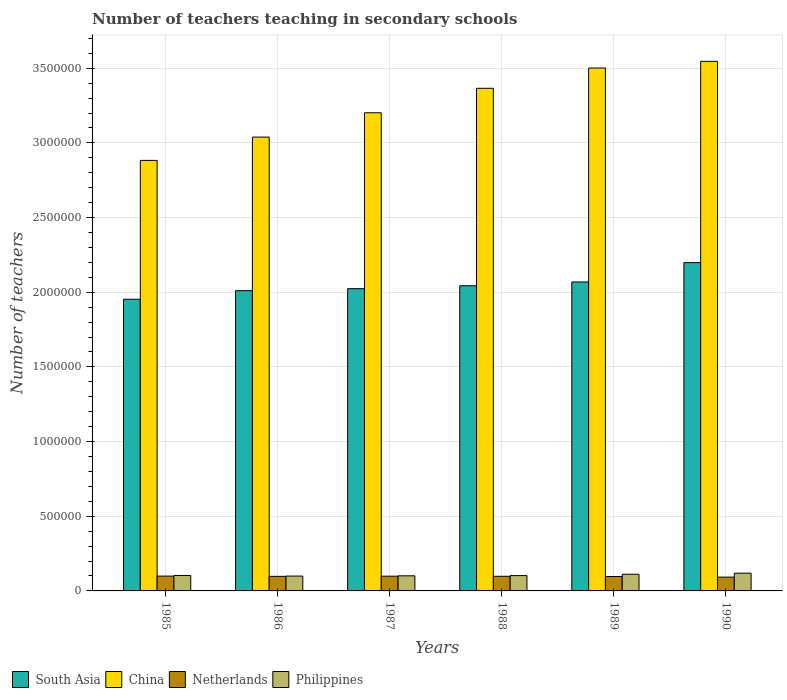Are the number of bars per tick equal to the number of legend labels?
Provide a succinct answer. Yes. How many bars are there on the 6th tick from the left?
Keep it short and to the point. 4. What is the number of teachers teaching in secondary schools in South Asia in 1989?
Ensure brevity in your answer.  2.07e+06. Across all years, what is the maximum number of teachers teaching in secondary schools in Philippines?
Your response must be concise. 1.19e+05. Across all years, what is the minimum number of teachers teaching in secondary schools in Netherlands?
Ensure brevity in your answer.  9.24e+04. In which year was the number of teachers teaching in secondary schools in South Asia maximum?
Your answer should be very brief. 1990. What is the total number of teachers teaching in secondary schools in Netherlands in the graph?
Ensure brevity in your answer.  5.82e+05. What is the difference between the number of teachers teaching in secondary schools in South Asia in 1985 and that in 1986?
Your response must be concise. -5.73e+04. What is the difference between the number of teachers teaching in secondary schools in South Asia in 1986 and the number of teachers teaching in secondary schools in China in 1990?
Provide a succinct answer. -1.54e+06. What is the average number of teachers teaching in secondary schools in South Asia per year?
Provide a succinct answer. 2.05e+06. In the year 1986, what is the difference between the number of teachers teaching in secondary schools in South Asia and number of teachers teaching in secondary schools in China?
Give a very brief answer. -1.03e+06. What is the ratio of the number of teachers teaching in secondary schools in Netherlands in 1986 to that in 1990?
Provide a short and direct response. 1.06. Is the number of teachers teaching in secondary schools in Philippines in 1986 less than that in 1989?
Provide a short and direct response. Yes. What is the difference between the highest and the second highest number of teachers teaching in secondary schools in South Asia?
Your answer should be compact. 1.30e+05. What is the difference between the highest and the lowest number of teachers teaching in secondary schools in China?
Ensure brevity in your answer.  6.63e+05. Is the sum of the number of teachers teaching in secondary schools in South Asia in 1986 and 1990 greater than the maximum number of teachers teaching in secondary schools in Netherlands across all years?
Give a very brief answer. Yes. What does the 3rd bar from the left in 1986 represents?
Your response must be concise. Netherlands. What does the 4th bar from the right in 1989 represents?
Offer a very short reply. South Asia. How many bars are there?
Give a very brief answer. 24. How many years are there in the graph?
Your answer should be very brief. 6. Are the values on the major ticks of Y-axis written in scientific E-notation?
Give a very brief answer. No. How many legend labels are there?
Your response must be concise. 4. How are the legend labels stacked?
Offer a very short reply. Horizontal. What is the title of the graph?
Your response must be concise. Number of teachers teaching in secondary schools. What is the label or title of the Y-axis?
Offer a very short reply. Number of teachers. What is the Number of teachers of South Asia in 1985?
Provide a succinct answer. 1.95e+06. What is the Number of teachers of China in 1985?
Keep it short and to the point. 2.88e+06. What is the Number of teachers in Netherlands in 1985?
Provide a succinct answer. 9.93e+04. What is the Number of teachers of Philippines in 1985?
Offer a very short reply. 1.03e+05. What is the Number of teachers in South Asia in 1986?
Offer a terse response. 2.01e+06. What is the Number of teachers of China in 1986?
Offer a very short reply. 3.04e+06. What is the Number of teachers in Netherlands in 1986?
Give a very brief answer. 9.76e+04. What is the Number of teachers of Philippines in 1986?
Keep it short and to the point. 9.95e+04. What is the Number of teachers of South Asia in 1987?
Make the answer very short. 2.02e+06. What is the Number of teachers in China in 1987?
Ensure brevity in your answer.  3.20e+06. What is the Number of teachers of Netherlands in 1987?
Keep it short and to the point. 9.87e+04. What is the Number of teachers in Philippines in 1987?
Ensure brevity in your answer.  1.01e+05. What is the Number of teachers of South Asia in 1988?
Ensure brevity in your answer.  2.04e+06. What is the Number of teachers of China in 1988?
Your response must be concise. 3.37e+06. What is the Number of teachers of Netherlands in 1988?
Ensure brevity in your answer.  9.80e+04. What is the Number of teachers of Philippines in 1988?
Keep it short and to the point. 1.03e+05. What is the Number of teachers of South Asia in 1989?
Ensure brevity in your answer.  2.07e+06. What is the Number of teachers of China in 1989?
Give a very brief answer. 3.50e+06. What is the Number of teachers in Netherlands in 1989?
Your response must be concise. 9.64e+04. What is the Number of teachers of Philippines in 1989?
Your response must be concise. 1.12e+05. What is the Number of teachers of South Asia in 1990?
Provide a short and direct response. 2.20e+06. What is the Number of teachers in China in 1990?
Your answer should be compact. 3.55e+06. What is the Number of teachers of Netherlands in 1990?
Offer a terse response. 9.24e+04. What is the Number of teachers in Philippines in 1990?
Provide a succinct answer. 1.19e+05. Across all years, what is the maximum Number of teachers of South Asia?
Offer a terse response. 2.20e+06. Across all years, what is the maximum Number of teachers of China?
Your answer should be very brief. 3.55e+06. Across all years, what is the maximum Number of teachers in Netherlands?
Offer a terse response. 9.93e+04. Across all years, what is the maximum Number of teachers in Philippines?
Provide a short and direct response. 1.19e+05. Across all years, what is the minimum Number of teachers of South Asia?
Offer a very short reply. 1.95e+06. Across all years, what is the minimum Number of teachers of China?
Keep it short and to the point. 2.88e+06. Across all years, what is the minimum Number of teachers in Netherlands?
Provide a succinct answer. 9.24e+04. Across all years, what is the minimum Number of teachers of Philippines?
Make the answer very short. 9.95e+04. What is the total Number of teachers in South Asia in the graph?
Your answer should be very brief. 1.23e+07. What is the total Number of teachers of China in the graph?
Provide a succinct answer. 1.95e+07. What is the total Number of teachers in Netherlands in the graph?
Ensure brevity in your answer.  5.82e+05. What is the total Number of teachers in Philippines in the graph?
Give a very brief answer. 6.37e+05. What is the difference between the Number of teachers of South Asia in 1985 and that in 1986?
Keep it short and to the point. -5.73e+04. What is the difference between the Number of teachers of China in 1985 and that in 1986?
Your answer should be very brief. -1.56e+05. What is the difference between the Number of teachers of Netherlands in 1985 and that in 1986?
Give a very brief answer. 1668. What is the difference between the Number of teachers of Philippines in 1985 and that in 1986?
Your response must be concise. 4025. What is the difference between the Number of teachers of South Asia in 1985 and that in 1987?
Offer a very short reply. -7.08e+04. What is the difference between the Number of teachers of China in 1985 and that in 1987?
Ensure brevity in your answer.  -3.19e+05. What is the difference between the Number of teachers of Netherlands in 1985 and that in 1987?
Offer a terse response. 534. What is the difference between the Number of teachers of Philippines in 1985 and that in 1987?
Keep it short and to the point. 2411. What is the difference between the Number of teachers of South Asia in 1985 and that in 1988?
Ensure brevity in your answer.  -9.04e+04. What is the difference between the Number of teachers of China in 1985 and that in 1988?
Provide a short and direct response. -4.83e+05. What is the difference between the Number of teachers of Netherlands in 1985 and that in 1988?
Provide a short and direct response. 1261. What is the difference between the Number of teachers of Philippines in 1985 and that in 1988?
Provide a short and direct response. 882. What is the difference between the Number of teachers in South Asia in 1985 and that in 1989?
Your answer should be compact. -1.16e+05. What is the difference between the Number of teachers in China in 1985 and that in 1989?
Provide a succinct answer. -6.18e+05. What is the difference between the Number of teachers of Netherlands in 1985 and that in 1989?
Offer a very short reply. 2882. What is the difference between the Number of teachers in Philippines in 1985 and that in 1989?
Your answer should be very brief. -8241. What is the difference between the Number of teachers of South Asia in 1985 and that in 1990?
Offer a very short reply. -2.45e+05. What is the difference between the Number of teachers of China in 1985 and that in 1990?
Your answer should be very brief. -6.63e+05. What is the difference between the Number of teachers in Netherlands in 1985 and that in 1990?
Your answer should be compact. 6819. What is the difference between the Number of teachers in Philippines in 1985 and that in 1990?
Keep it short and to the point. -1.53e+04. What is the difference between the Number of teachers of South Asia in 1986 and that in 1987?
Keep it short and to the point. -1.35e+04. What is the difference between the Number of teachers in China in 1986 and that in 1987?
Keep it short and to the point. -1.63e+05. What is the difference between the Number of teachers in Netherlands in 1986 and that in 1987?
Provide a succinct answer. -1134. What is the difference between the Number of teachers in Philippines in 1986 and that in 1987?
Keep it short and to the point. -1614. What is the difference between the Number of teachers of South Asia in 1986 and that in 1988?
Provide a succinct answer. -3.31e+04. What is the difference between the Number of teachers of China in 1986 and that in 1988?
Make the answer very short. -3.27e+05. What is the difference between the Number of teachers of Netherlands in 1986 and that in 1988?
Ensure brevity in your answer.  -407. What is the difference between the Number of teachers of Philippines in 1986 and that in 1988?
Offer a very short reply. -3143. What is the difference between the Number of teachers in South Asia in 1986 and that in 1989?
Ensure brevity in your answer.  -5.83e+04. What is the difference between the Number of teachers of China in 1986 and that in 1989?
Provide a succinct answer. -4.62e+05. What is the difference between the Number of teachers in Netherlands in 1986 and that in 1989?
Offer a very short reply. 1214. What is the difference between the Number of teachers of Philippines in 1986 and that in 1989?
Keep it short and to the point. -1.23e+04. What is the difference between the Number of teachers of South Asia in 1986 and that in 1990?
Offer a terse response. -1.88e+05. What is the difference between the Number of teachers in China in 1986 and that in 1990?
Provide a short and direct response. -5.07e+05. What is the difference between the Number of teachers in Netherlands in 1986 and that in 1990?
Make the answer very short. 5151. What is the difference between the Number of teachers of Philippines in 1986 and that in 1990?
Provide a short and direct response. -1.93e+04. What is the difference between the Number of teachers in South Asia in 1987 and that in 1988?
Your response must be concise. -1.96e+04. What is the difference between the Number of teachers in China in 1987 and that in 1988?
Give a very brief answer. -1.64e+05. What is the difference between the Number of teachers in Netherlands in 1987 and that in 1988?
Your answer should be compact. 727. What is the difference between the Number of teachers of Philippines in 1987 and that in 1988?
Keep it short and to the point. -1529. What is the difference between the Number of teachers in South Asia in 1987 and that in 1989?
Your answer should be very brief. -4.48e+04. What is the difference between the Number of teachers of China in 1987 and that in 1989?
Give a very brief answer. -3.00e+05. What is the difference between the Number of teachers in Netherlands in 1987 and that in 1989?
Provide a short and direct response. 2348. What is the difference between the Number of teachers of Philippines in 1987 and that in 1989?
Provide a short and direct response. -1.07e+04. What is the difference between the Number of teachers of South Asia in 1987 and that in 1990?
Keep it short and to the point. -1.75e+05. What is the difference between the Number of teachers of China in 1987 and that in 1990?
Provide a succinct answer. -3.44e+05. What is the difference between the Number of teachers of Netherlands in 1987 and that in 1990?
Make the answer very short. 6285. What is the difference between the Number of teachers of Philippines in 1987 and that in 1990?
Give a very brief answer. -1.77e+04. What is the difference between the Number of teachers in South Asia in 1988 and that in 1989?
Ensure brevity in your answer.  -2.53e+04. What is the difference between the Number of teachers in China in 1988 and that in 1989?
Make the answer very short. -1.36e+05. What is the difference between the Number of teachers of Netherlands in 1988 and that in 1989?
Ensure brevity in your answer.  1621. What is the difference between the Number of teachers in Philippines in 1988 and that in 1989?
Make the answer very short. -9123. What is the difference between the Number of teachers in South Asia in 1988 and that in 1990?
Your answer should be compact. -1.55e+05. What is the difference between the Number of teachers in China in 1988 and that in 1990?
Offer a terse response. -1.80e+05. What is the difference between the Number of teachers in Netherlands in 1988 and that in 1990?
Provide a short and direct response. 5558. What is the difference between the Number of teachers in Philippines in 1988 and that in 1990?
Your response must be concise. -1.62e+04. What is the difference between the Number of teachers in South Asia in 1989 and that in 1990?
Your response must be concise. -1.30e+05. What is the difference between the Number of teachers in China in 1989 and that in 1990?
Your response must be concise. -4.47e+04. What is the difference between the Number of teachers of Netherlands in 1989 and that in 1990?
Your answer should be compact. 3937. What is the difference between the Number of teachers of Philippines in 1989 and that in 1990?
Your answer should be compact. -7071. What is the difference between the Number of teachers in South Asia in 1985 and the Number of teachers in China in 1986?
Make the answer very short. -1.09e+06. What is the difference between the Number of teachers of South Asia in 1985 and the Number of teachers of Netherlands in 1986?
Your answer should be compact. 1.86e+06. What is the difference between the Number of teachers of South Asia in 1985 and the Number of teachers of Philippines in 1986?
Your answer should be compact. 1.85e+06. What is the difference between the Number of teachers in China in 1985 and the Number of teachers in Netherlands in 1986?
Keep it short and to the point. 2.79e+06. What is the difference between the Number of teachers of China in 1985 and the Number of teachers of Philippines in 1986?
Offer a very short reply. 2.78e+06. What is the difference between the Number of teachers of Netherlands in 1985 and the Number of teachers of Philippines in 1986?
Provide a short and direct response. -205. What is the difference between the Number of teachers of South Asia in 1985 and the Number of teachers of China in 1987?
Make the answer very short. -1.25e+06. What is the difference between the Number of teachers in South Asia in 1985 and the Number of teachers in Netherlands in 1987?
Give a very brief answer. 1.85e+06. What is the difference between the Number of teachers in South Asia in 1985 and the Number of teachers in Philippines in 1987?
Your answer should be compact. 1.85e+06. What is the difference between the Number of teachers of China in 1985 and the Number of teachers of Netherlands in 1987?
Your answer should be very brief. 2.78e+06. What is the difference between the Number of teachers of China in 1985 and the Number of teachers of Philippines in 1987?
Offer a terse response. 2.78e+06. What is the difference between the Number of teachers in Netherlands in 1985 and the Number of teachers in Philippines in 1987?
Give a very brief answer. -1819. What is the difference between the Number of teachers of South Asia in 1985 and the Number of teachers of China in 1988?
Provide a short and direct response. -1.41e+06. What is the difference between the Number of teachers in South Asia in 1985 and the Number of teachers in Netherlands in 1988?
Your answer should be compact. 1.86e+06. What is the difference between the Number of teachers of South Asia in 1985 and the Number of teachers of Philippines in 1988?
Your response must be concise. 1.85e+06. What is the difference between the Number of teachers in China in 1985 and the Number of teachers in Netherlands in 1988?
Ensure brevity in your answer.  2.78e+06. What is the difference between the Number of teachers of China in 1985 and the Number of teachers of Philippines in 1988?
Your answer should be very brief. 2.78e+06. What is the difference between the Number of teachers of Netherlands in 1985 and the Number of teachers of Philippines in 1988?
Give a very brief answer. -3348. What is the difference between the Number of teachers in South Asia in 1985 and the Number of teachers in China in 1989?
Your answer should be very brief. -1.55e+06. What is the difference between the Number of teachers in South Asia in 1985 and the Number of teachers in Netherlands in 1989?
Ensure brevity in your answer.  1.86e+06. What is the difference between the Number of teachers in South Asia in 1985 and the Number of teachers in Philippines in 1989?
Provide a short and direct response. 1.84e+06. What is the difference between the Number of teachers in China in 1985 and the Number of teachers in Netherlands in 1989?
Offer a very short reply. 2.79e+06. What is the difference between the Number of teachers of China in 1985 and the Number of teachers of Philippines in 1989?
Make the answer very short. 2.77e+06. What is the difference between the Number of teachers in Netherlands in 1985 and the Number of teachers in Philippines in 1989?
Your answer should be very brief. -1.25e+04. What is the difference between the Number of teachers of South Asia in 1985 and the Number of teachers of China in 1990?
Your answer should be compact. -1.59e+06. What is the difference between the Number of teachers in South Asia in 1985 and the Number of teachers in Netherlands in 1990?
Keep it short and to the point. 1.86e+06. What is the difference between the Number of teachers in South Asia in 1985 and the Number of teachers in Philippines in 1990?
Ensure brevity in your answer.  1.83e+06. What is the difference between the Number of teachers of China in 1985 and the Number of teachers of Netherlands in 1990?
Keep it short and to the point. 2.79e+06. What is the difference between the Number of teachers in China in 1985 and the Number of teachers in Philippines in 1990?
Your answer should be compact. 2.76e+06. What is the difference between the Number of teachers of Netherlands in 1985 and the Number of teachers of Philippines in 1990?
Offer a terse response. -1.95e+04. What is the difference between the Number of teachers of South Asia in 1986 and the Number of teachers of China in 1987?
Provide a short and direct response. -1.19e+06. What is the difference between the Number of teachers of South Asia in 1986 and the Number of teachers of Netherlands in 1987?
Offer a terse response. 1.91e+06. What is the difference between the Number of teachers in South Asia in 1986 and the Number of teachers in Philippines in 1987?
Your answer should be very brief. 1.91e+06. What is the difference between the Number of teachers of China in 1986 and the Number of teachers of Netherlands in 1987?
Provide a short and direct response. 2.94e+06. What is the difference between the Number of teachers of China in 1986 and the Number of teachers of Philippines in 1987?
Your answer should be very brief. 2.94e+06. What is the difference between the Number of teachers in Netherlands in 1986 and the Number of teachers in Philippines in 1987?
Offer a terse response. -3487. What is the difference between the Number of teachers in South Asia in 1986 and the Number of teachers in China in 1988?
Make the answer very short. -1.36e+06. What is the difference between the Number of teachers of South Asia in 1986 and the Number of teachers of Netherlands in 1988?
Ensure brevity in your answer.  1.91e+06. What is the difference between the Number of teachers of South Asia in 1986 and the Number of teachers of Philippines in 1988?
Your answer should be very brief. 1.91e+06. What is the difference between the Number of teachers of China in 1986 and the Number of teachers of Netherlands in 1988?
Keep it short and to the point. 2.94e+06. What is the difference between the Number of teachers of China in 1986 and the Number of teachers of Philippines in 1988?
Ensure brevity in your answer.  2.94e+06. What is the difference between the Number of teachers in Netherlands in 1986 and the Number of teachers in Philippines in 1988?
Provide a short and direct response. -5016. What is the difference between the Number of teachers of South Asia in 1986 and the Number of teachers of China in 1989?
Provide a succinct answer. -1.49e+06. What is the difference between the Number of teachers of South Asia in 1986 and the Number of teachers of Netherlands in 1989?
Give a very brief answer. 1.91e+06. What is the difference between the Number of teachers of South Asia in 1986 and the Number of teachers of Philippines in 1989?
Offer a very short reply. 1.90e+06. What is the difference between the Number of teachers in China in 1986 and the Number of teachers in Netherlands in 1989?
Keep it short and to the point. 2.94e+06. What is the difference between the Number of teachers of China in 1986 and the Number of teachers of Philippines in 1989?
Your response must be concise. 2.93e+06. What is the difference between the Number of teachers in Netherlands in 1986 and the Number of teachers in Philippines in 1989?
Give a very brief answer. -1.41e+04. What is the difference between the Number of teachers of South Asia in 1986 and the Number of teachers of China in 1990?
Ensure brevity in your answer.  -1.54e+06. What is the difference between the Number of teachers in South Asia in 1986 and the Number of teachers in Netherlands in 1990?
Your response must be concise. 1.92e+06. What is the difference between the Number of teachers of South Asia in 1986 and the Number of teachers of Philippines in 1990?
Keep it short and to the point. 1.89e+06. What is the difference between the Number of teachers of China in 1986 and the Number of teachers of Netherlands in 1990?
Your answer should be very brief. 2.95e+06. What is the difference between the Number of teachers in China in 1986 and the Number of teachers in Philippines in 1990?
Ensure brevity in your answer.  2.92e+06. What is the difference between the Number of teachers in Netherlands in 1986 and the Number of teachers in Philippines in 1990?
Give a very brief answer. -2.12e+04. What is the difference between the Number of teachers of South Asia in 1987 and the Number of teachers of China in 1988?
Keep it short and to the point. -1.34e+06. What is the difference between the Number of teachers of South Asia in 1987 and the Number of teachers of Netherlands in 1988?
Your answer should be very brief. 1.93e+06. What is the difference between the Number of teachers of South Asia in 1987 and the Number of teachers of Philippines in 1988?
Offer a terse response. 1.92e+06. What is the difference between the Number of teachers of China in 1987 and the Number of teachers of Netherlands in 1988?
Give a very brief answer. 3.10e+06. What is the difference between the Number of teachers of China in 1987 and the Number of teachers of Philippines in 1988?
Offer a very short reply. 3.10e+06. What is the difference between the Number of teachers in Netherlands in 1987 and the Number of teachers in Philippines in 1988?
Offer a terse response. -3882. What is the difference between the Number of teachers of South Asia in 1987 and the Number of teachers of China in 1989?
Your answer should be very brief. -1.48e+06. What is the difference between the Number of teachers of South Asia in 1987 and the Number of teachers of Netherlands in 1989?
Make the answer very short. 1.93e+06. What is the difference between the Number of teachers in South Asia in 1987 and the Number of teachers in Philippines in 1989?
Your answer should be compact. 1.91e+06. What is the difference between the Number of teachers of China in 1987 and the Number of teachers of Netherlands in 1989?
Keep it short and to the point. 3.11e+06. What is the difference between the Number of teachers in China in 1987 and the Number of teachers in Philippines in 1989?
Make the answer very short. 3.09e+06. What is the difference between the Number of teachers in Netherlands in 1987 and the Number of teachers in Philippines in 1989?
Your response must be concise. -1.30e+04. What is the difference between the Number of teachers in South Asia in 1987 and the Number of teachers in China in 1990?
Make the answer very short. -1.52e+06. What is the difference between the Number of teachers of South Asia in 1987 and the Number of teachers of Netherlands in 1990?
Offer a very short reply. 1.93e+06. What is the difference between the Number of teachers of South Asia in 1987 and the Number of teachers of Philippines in 1990?
Your answer should be very brief. 1.91e+06. What is the difference between the Number of teachers in China in 1987 and the Number of teachers in Netherlands in 1990?
Keep it short and to the point. 3.11e+06. What is the difference between the Number of teachers of China in 1987 and the Number of teachers of Philippines in 1990?
Offer a terse response. 3.08e+06. What is the difference between the Number of teachers in Netherlands in 1987 and the Number of teachers in Philippines in 1990?
Provide a short and direct response. -2.01e+04. What is the difference between the Number of teachers in South Asia in 1988 and the Number of teachers in China in 1989?
Provide a short and direct response. -1.46e+06. What is the difference between the Number of teachers in South Asia in 1988 and the Number of teachers in Netherlands in 1989?
Make the answer very short. 1.95e+06. What is the difference between the Number of teachers of South Asia in 1988 and the Number of teachers of Philippines in 1989?
Make the answer very short. 1.93e+06. What is the difference between the Number of teachers of China in 1988 and the Number of teachers of Netherlands in 1989?
Make the answer very short. 3.27e+06. What is the difference between the Number of teachers in China in 1988 and the Number of teachers in Philippines in 1989?
Your answer should be compact. 3.25e+06. What is the difference between the Number of teachers of Netherlands in 1988 and the Number of teachers of Philippines in 1989?
Make the answer very short. -1.37e+04. What is the difference between the Number of teachers of South Asia in 1988 and the Number of teachers of China in 1990?
Provide a succinct answer. -1.50e+06. What is the difference between the Number of teachers in South Asia in 1988 and the Number of teachers in Netherlands in 1990?
Your response must be concise. 1.95e+06. What is the difference between the Number of teachers of South Asia in 1988 and the Number of teachers of Philippines in 1990?
Provide a short and direct response. 1.92e+06. What is the difference between the Number of teachers of China in 1988 and the Number of teachers of Netherlands in 1990?
Your response must be concise. 3.27e+06. What is the difference between the Number of teachers in China in 1988 and the Number of teachers in Philippines in 1990?
Provide a succinct answer. 3.25e+06. What is the difference between the Number of teachers of Netherlands in 1988 and the Number of teachers of Philippines in 1990?
Make the answer very short. -2.08e+04. What is the difference between the Number of teachers in South Asia in 1989 and the Number of teachers in China in 1990?
Provide a short and direct response. -1.48e+06. What is the difference between the Number of teachers in South Asia in 1989 and the Number of teachers in Netherlands in 1990?
Provide a short and direct response. 1.98e+06. What is the difference between the Number of teachers in South Asia in 1989 and the Number of teachers in Philippines in 1990?
Your answer should be compact. 1.95e+06. What is the difference between the Number of teachers in China in 1989 and the Number of teachers in Netherlands in 1990?
Give a very brief answer. 3.41e+06. What is the difference between the Number of teachers in China in 1989 and the Number of teachers in Philippines in 1990?
Give a very brief answer. 3.38e+06. What is the difference between the Number of teachers of Netherlands in 1989 and the Number of teachers of Philippines in 1990?
Keep it short and to the point. -2.24e+04. What is the average Number of teachers in South Asia per year?
Offer a very short reply. 2.05e+06. What is the average Number of teachers of China per year?
Ensure brevity in your answer.  3.26e+06. What is the average Number of teachers of Netherlands per year?
Offer a terse response. 9.71e+04. What is the average Number of teachers in Philippines per year?
Keep it short and to the point. 1.06e+05. In the year 1985, what is the difference between the Number of teachers in South Asia and Number of teachers in China?
Keep it short and to the point. -9.30e+05. In the year 1985, what is the difference between the Number of teachers in South Asia and Number of teachers in Netherlands?
Keep it short and to the point. 1.85e+06. In the year 1985, what is the difference between the Number of teachers of South Asia and Number of teachers of Philippines?
Give a very brief answer. 1.85e+06. In the year 1985, what is the difference between the Number of teachers of China and Number of teachers of Netherlands?
Your response must be concise. 2.78e+06. In the year 1985, what is the difference between the Number of teachers of China and Number of teachers of Philippines?
Ensure brevity in your answer.  2.78e+06. In the year 1985, what is the difference between the Number of teachers of Netherlands and Number of teachers of Philippines?
Your answer should be very brief. -4230. In the year 1986, what is the difference between the Number of teachers of South Asia and Number of teachers of China?
Your answer should be compact. -1.03e+06. In the year 1986, what is the difference between the Number of teachers of South Asia and Number of teachers of Netherlands?
Offer a very short reply. 1.91e+06. In the year 1986, what is the difference between the Number of teachers in South Asia and Number of teachers in Philippines?
Provide a succinct answer. 1.91e+06. In the year 1986, what is the difference between the Number of teachers of China and Number of teachers of Netherlands?
Provide a succinct answer. 2.94e+06. In the year 1986, what is the difference between the Number of teachers of China and Number of teachers of Philippines?
Ensure brevity in your answer.  2.94e+06. In the year 1986, what is the difference between the Number of teachers of Netherlands and Number of teachers of Philippines?
Ensure brevity in your answer.  -1873. In the year 1987, what is the difference between the Number of teachers of South Asia and Number of teachers of China?
Provide a succinct answer. -1.18e+06. In the year 1987, what is the difference between the Number of teachers in South Asia and Number of teachers in Netherlands?
Your answer should be compact. 1.93e+06. In the year 1987, what is the difference between the Number of teachers in South Asia and Number of teachers in Philippines?
Provide a short and direct response. 1.92e+06. In the year 1987, what is the difference between the Number of teachers in China and Number of teachers in Netherlands?
Your answer should be very brief. 3.10e+06. In the year 1987, what is the difference between the Number of teachers in China and Number of teachers in Philippines?
Your response must be concise. 3.10e+06. In the year 1987, what is the difference between the Number of teachers in Netherlands and Number of teachers in Philippines?
Your answer should be very brief. -2353. In the year 1988, what is the difference between the Number of teachers of South Asia and Number of teachers of China?
Your answer should be very brief. -1.32e+06. In the year 1988, what is the difference between the Number of teachers in South Asia and Number of teachers in Netherlands?
Your response must be concise. 1.95e+06. In the year 1988, what is the difference between the Number of teachers in South Asia and Number of teachers in Philippines?
Ensure brevity in your answer.  1.94e+06. In the year 1988, what is the difference between the Number of teachers of China and Number of teachers of Netherlands?
Offer a very short reply. 3.27e+06. In the year 1988, what is the difference between the Number of teachers in China and Number of teachers in Philippines?
Provide a short and direct response. 3.26e+06. In the year 1988, what is the difference between the Number of teachers of Netherlands and Number of teachers of Philippines?
Offer a terse response. -4609. In the year 1989, what is the difference between the Number of teachers in South Asia and Number of teachers in China?
Your answer should be very brief. -1.43e+06. In the year 1989, what is the difference between the Number of teachers in South Asia and Number of teachers in Netherlands?
Your answer should be very brief. 1.97e+06. In the year 1989, what is the difference between the Number of teachers of South Asia and Number of teachers of Philippines?
Keep it short and to the point. 1.96e+06. In the year 1989, what is the difference between the Number of teachers in China and Number of teachers in Netherlands?
Offer a very short reply. 3.41e+06. In the year 1989, what is the difference between the Number of teachers in China and Number of teachers in Philippines?
Provide a short and direct response. 3.39e+06. In the year 1989, what is the difference between the Number of teachers of Netherlands and Number of teachers of Philippines?
Provide a short and direct response. -1.54e+04. In the year 1990, what is the difference between the Number of teachers of South Asia and Number of teachers of China?
Offer a terse response. -1.35e+06. In the year 1990, what is the difference between the Number of teachers in South Asia and Number of teachers in Netherlands?
Offer a terse response. 2.11e+06. In the year 1990, what is the difference between the Number of teachers of South Asia and Number of teachers of Philippines?
Make the answer very short. 2.08e+06. In the year 1990, what is the difference between the Number of teachers in China and Number of teachers in Netherlands?
Your response must be concise. 3.45e+06. In the year 1990, what is the difference between the Number of teachers in China and Number of teachers in Philippines?
Provide a succinct answer. 3.43e+06. In the year 1990, what is the difference between the Number of teachers of Netherlands and Number of teachers of Philippines?
Your response must be concise. -2.64e+04. What is the ratio of the Number of teachers in South Asia in 1985 to that in 1986?
Provide a short and direct response. 0.97. What is the ratio of the Number of teachers in China in 1985 to that in 1986?
Provide a succinct answer. 0.95. What is the ratio of the Number of teachers of Netherlands in 1985 to that in 1986?
Your answer should be compact. 1.02. What is the ratio of the Number of teachers of Philippines in 1985 to that in 1986?
Give a very brief answer. 1.04. What is the ratio of the Number of teachers in China in 1985 to that in 1987?
Give a very brief answer. 0.9. What is the ratio of the Number of teachers of Netherlands in 1985 to that in 1987?
Your answer should be compact. 1.01. What is the ratio of the Number of teachers of Philippines in 1985 to that in 1987?
Offer a very short reply. 1.02. What is the ratio of the Number of teachers in South Asia in 1985 to that in 1988?
Make the answer very short. 0.96. What is the ratio of the Number of teachers of China in 1985 to that in 1988?
Offer a terse response. 0.86. What is the ratio of the Number of teachers in Netherlands in 1985 to that in 1988?
Provide a short and direct response. 1.01. What is the ratio of the Number of teachers of Philippines in 1985 to that in 1988?
Give a very brief answer. 1.01. What is the ratio of the Number of teachers of South Asia in 1985 to that in 1989?
Provide a succinct answer. 0.94. What is the ratio of the Number of teachers of China in 1985 to that in 1989?
Your response must be concise. 0.82. What is the ratio of the Number of teachers of Netherlands in 1985 to that in 1989?
Provide a short and direct response. 1.03. What is the ratio of the Number of teachers in Philippines in 1985 to that in 1989?
Ensure brevity in your answer.  0.93. What is the ratio of the Number of teachers in South Asia in 1985 to that in 1990?
Offer a very short reply. 0.89. What is the ratio of the Number of teachers of China in 1985 to that in 1990?
Keep it short and to the point. 0.81. What is the ratio of the Number of teachers in Netherlands in 1985 to that in 1990?
Provide a short and direct response. 1.07. What is the ratio of the Number of teachers of Philippines in 1985 to that in 1990?
Provide a short and direct response. 0.87. What is the ratio of the Number of teachers of South Asia in 1986 to that in 1987?
Make the answer very short. 0.99. What is the ratio of the Number of teachers of China in 1986 to that in 1987?
Your answer should be very brief. 0.95. What is the ratio of the Number of teachers in Netherlands in 1986 to that in 1987?
Offer a very short reply. 0.99. What is the ratio of the Number of teachers in South Asia in 1986 to that in 1988?
Make the answer very short. 0.98. What is the ratio of the Number of teachers in China in 1986 to that in 1988?
Provide a short and direct response. 0.9. What is the ratio of the Number of teachers in Netherlands in 1986 to that in 1988?
Provide a succinct answer. 1. What is the ratio of the Number of teachers in Philippines in 1986 to that in 1988?
Your response must be concise. 0.97. What is the ratio of the Number of teachers in South Asia in 1986 to that in 1989?
Give a very brief answer. 0.97. What is the ratio of the Number of teachers in China in 1986 to that in 1989?
Ensure brevity in your answer.  0.87. What is the ratio of the Number of teachers in Netherlands in 1986 to that in 1989?
Offer a terse response. 1.01. What is the ratio of the Number of teachers in Philippines in 1986 to that in 1989?
Your answer should be compact. 0.89. What is the ratio of the Number of teachers of South Asia in 1986 to that in 1990?
Provide a succinct answer. 0.91. What is the ratio of the Number of teachers of China in 1986 to that in 1990?
Your answer should be compact. 0.86. What is the ratio of the Number of teachers in Netherlands in 1986 to that in 1990?
Ensure brevity in your answer.  1.06. What is the ratio of the Number of teachers of Philippines in 1986 to that in 1990?
Offer a terse response. 0.84. What is the ratio of the Number of teachers of South Asia in 1987 to that in 1988?
Offer a very short reply. 0.99. What is the ratio of the Number of teachers in China in 1987 to that in 1988?
Your answer should be very brief. 0.95. What is the ratio of the Number of teachers in Netherlands in 1987 to that in 1988?
Your answer should be compact. 1.01. What is the ratio of the Number of teachers of Philippines in 1987 to that in 1988?
Your answer should be very brief. 0.99. What is the ratio of the Number of teachers in South Asia in 1987 to that in 1989?
Your answer should be compact. 0.98. What is the ratio of the Number of teachers in China in 1987 to that in 1989?
Provide a succinct answer. 0.91. What is the ratio of the Number of teachers of Netherlands in 1987 to that in 1989?
Your answer should be very brief. 1.02. What is the ratio of the Number of teachers in Philippines in 1987 to that in 1989?
Offer a terse response. 0.9. What is the ratio of the Number of teachers of South Asia in 1987 to that in 1990?
Offer a very short reply. 0.92. What is the ratio of the Number of teachers in China in 1987 to that in 1990?
Ensure brevity in your answer.  0.9. What is the ratio of the Number of teachers in Netherlands in 1987 to that in 1990?
Your answer should be very brief. 1.07. What is the ratio of the Number of teachers in Philippines in 1987 to that in 1990?
Your response must be concise. 0.85. What is the ratio of the Number of teachers of South Asia in 1988 to that in 1989?
Provide a short and direct response. 0.99. What is the ratio of the Number of teachers in China in 1988 to that in 1989?
Provide a succinct answer. 0.96. What is the ratio of the Number of teachers in Netherlands in 1988 to that in 1989?
Your answer should be very brief. 1.02. What is the ratio of the Number of teachers of Philippines in 1988 to that in 1989?
Give a very brief answer. 0.92. What is the ratio of the Number of teachers of South Asia in 1988 to that in 1990?
Ensure brevity in your answer.  0.93. What is the ratio of the Number of teachers in China in 1988 to that in 1990?
Ensure brevity in your answer.  0.95. What is the ratio of the Number of teachers of Netherlands in 1988 to that in 1990?
Offer a terse response. 1.06. What is the ratio of the Number of teachers of Philippines in 1988 to that in 1990?
Offer a very short reply. 0.86. What is the ratio of the Number of teachers of South Asia in 1989 to that in 1990?
Keep it short and to the point. 0.94. What is the ratio of the Number of teachers of China in 1989 to that in 1990?
Keep it short and to the point. 0.99. What is the ratio of the Number of teachers in Netherlands in 1989 to that in 1990?
Offer a very short reply. 1.04. What is the ratio of the Number of teachers in Philippines in 1989 to that in 1990?
Your answer should be compact. 0.94. What is the difference between the highest and the second highest Number of teachers of South Asia?
Provide a short and direct response. 1.30e+05. What is the difference between the highest and the second highest Number of teachers of China?
Your answer should be compact. 4.47e+04. What is the difference between the highest and the second highest Number of teachers in Netherlands?
Your answer should be compact. 534. What is the difference between the highest and the second highest Number of teachers in Philippines?
Ensure brevity in your answer.  7071. What is the difference between the highest and the lowest Number of teachers of South Asia?
Ensure brevity in your answer.  2.45e+05. What is the difference between the highest and the lowest Number of teachers of China?
Your response must be concise. 6.63e+05. What is the difference between the highest and the lowest Number of teachers in Netherlands?
Keep it short and to the point. 6819. What is the difference between the highest and the lowest Number of teachers in Philippines?
Your answer should be compact. 1.93e+04. 